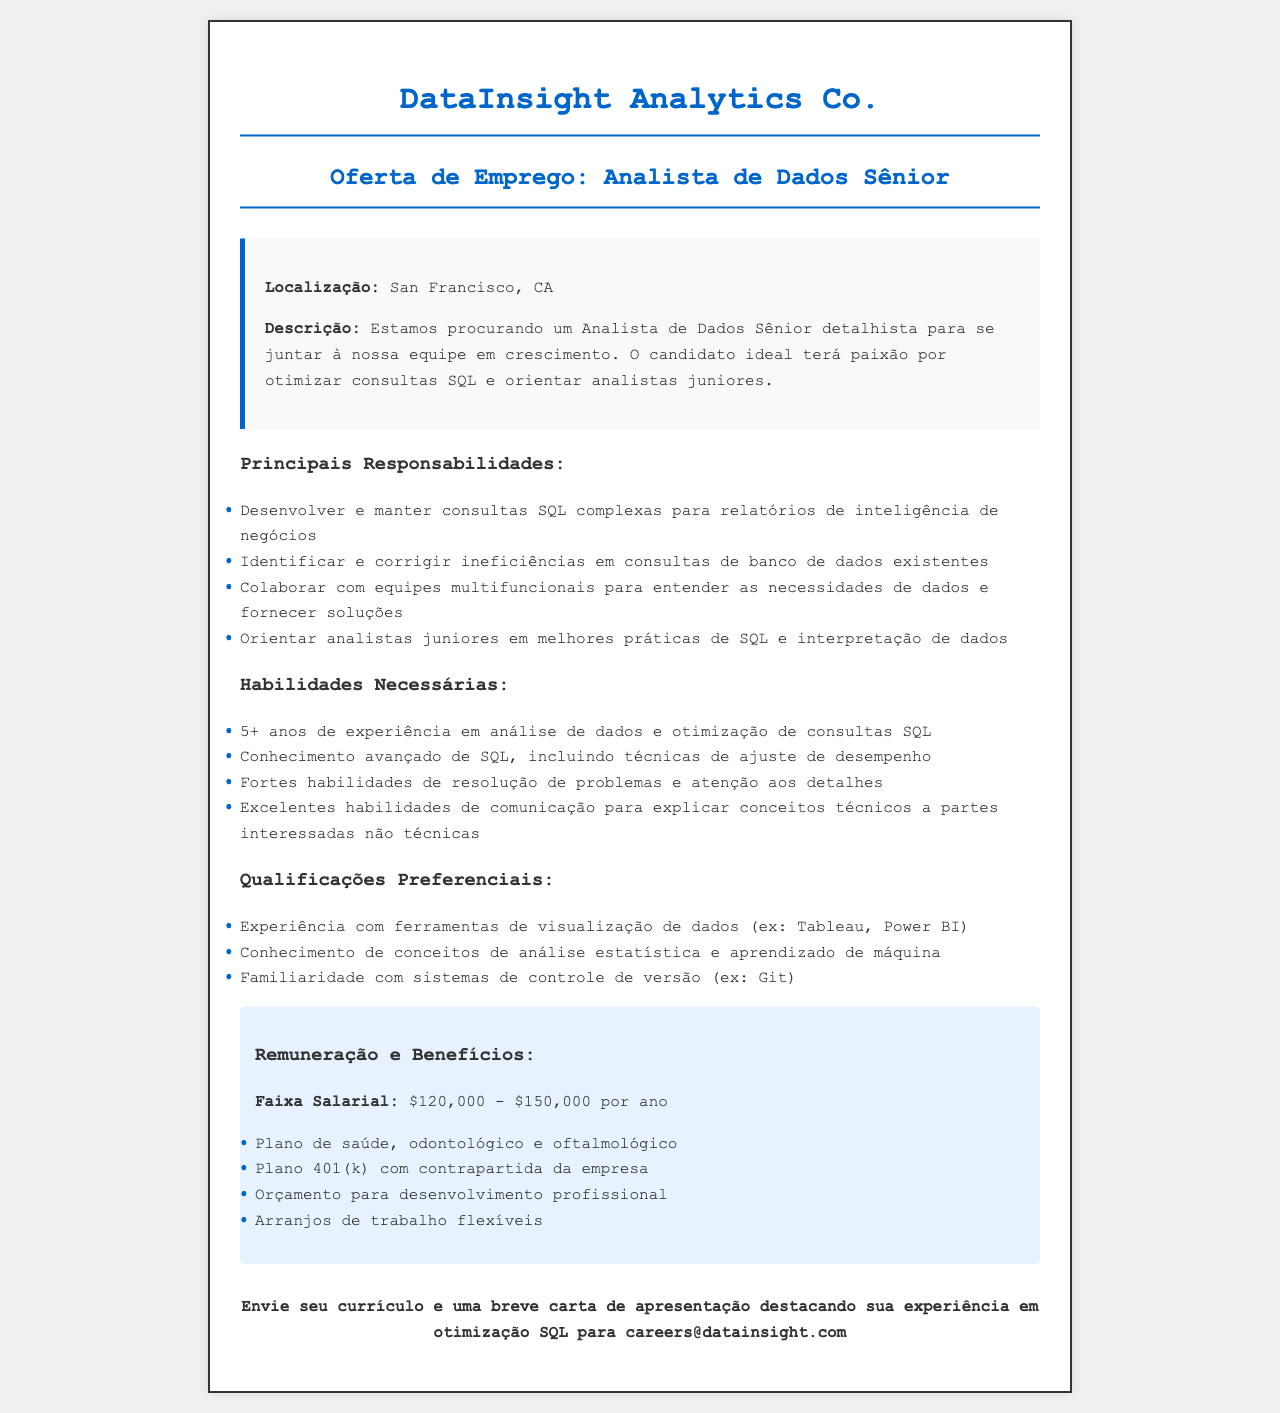Qual é o título da vaga? O título da vaga é mencionado na seção de oferta de emprego do documento.
Answer: Analista de Dados Sênior Qual é a localização do trabalho? A localização do trabalho é especificada logo após a descrição da vaga.
Answer: San Francisco, CA Qual é a faixa salarial oferecida? A faixa salarial é informada na seção sobre remuneração e benefícios do documento.
Answer: $120,000 - $150,000 por ano Quantos anos de experiência são exigidos? A exigência de experiência é mencionada nas habilidades necessárias da vaga.
Answer: 5+ anos Qual empresa está fazendo a oferta? O nome da empresa é apresentado no cabeçalho do documento.
Answer: DataInsight Analytics Co Quais são os benefícios mencionados? Os benefícios são listados na seção de remuneração e benefícios.
Answer: Plano de saúde, odontológico e oftalmológico Qual é uma das principais responsabilidades do cargo? Uma das responsabilidades principais é listada logo após o título de responsabilidades principais.
Answer: Desenvolver e manter consultas SQL complexas Como os candidatos devem se inscrever? A informação sobre como se inscrever está presente no final do documento.
Answer: Envie seu currículo e uma breve carta de apresentação Qual é uma qualificação preferencial mencionada? As qualificações preferenciais são listadas em sua própria seção no documento.
Answer: Experiência com ferramentas de visualização de dados 